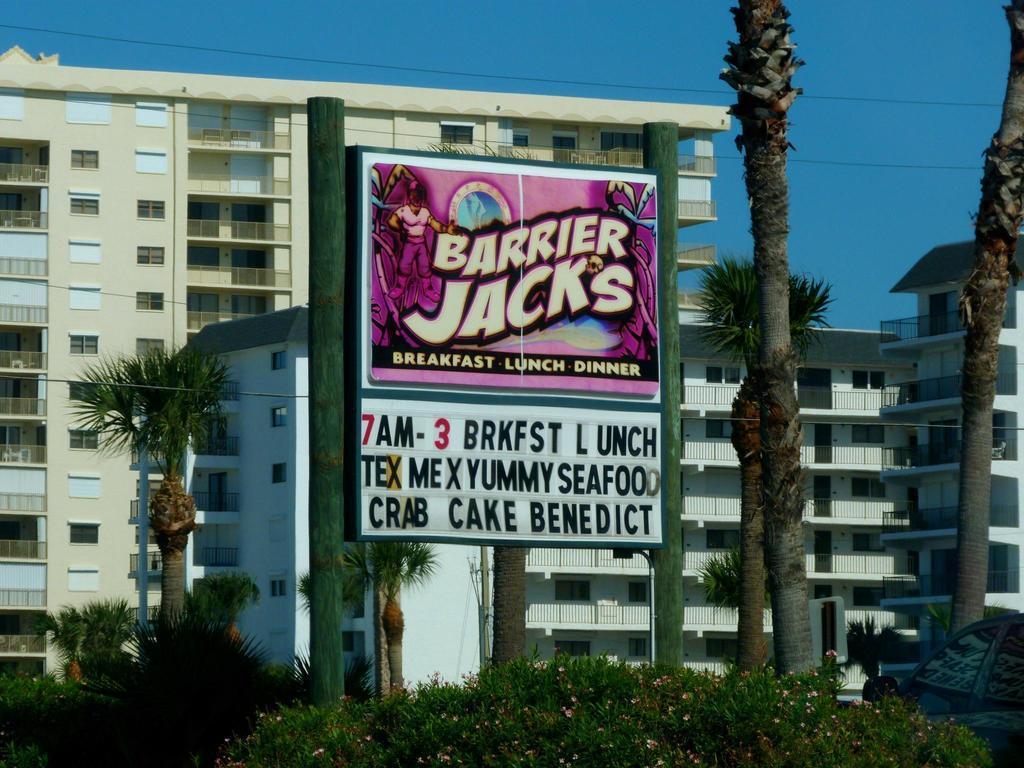Could you give a brief overview of what you see in this image? In this image, we can see some trees and buildings. There are some plants at the bottom of the image. There is a board in the middle of the image. There is a sky at the top of the image. 